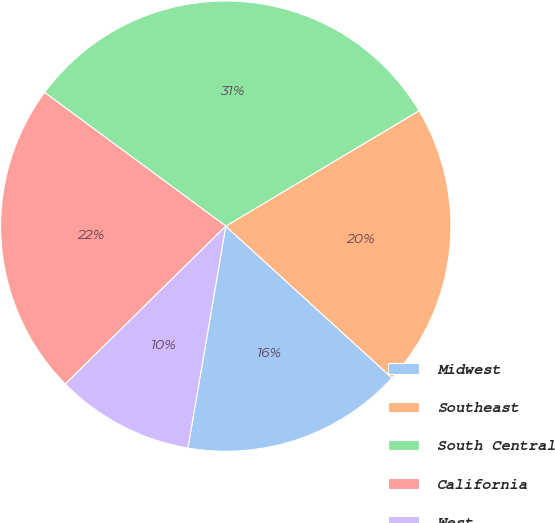<chart> <loc_0><loc_0><loc_500><loc_500><pie_chart><fcel>Midwest<fcel>Southeast<fcel>South Central<fcel>California<fcel>West<nl><fcel>15.91%<fcel>20.35%<fcel>31.32%<fcel>22.49%<fcel>9.94%<nl></chart> 